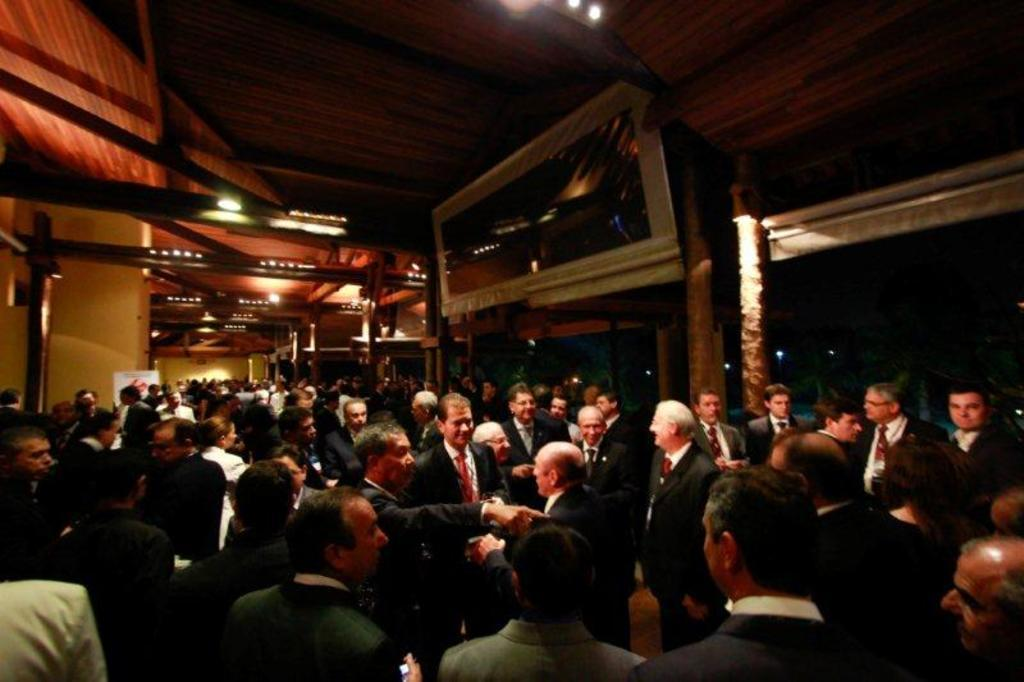What can be seen in the image involving people? There are people standing in the image. What architectural features are visible in the image? There are doors and pillars in the image. What is in the background of the image? There is a wall and lights in the background of the image. What type of jam is being spread on the bike in the image? There is no bike or jam present in the image. 